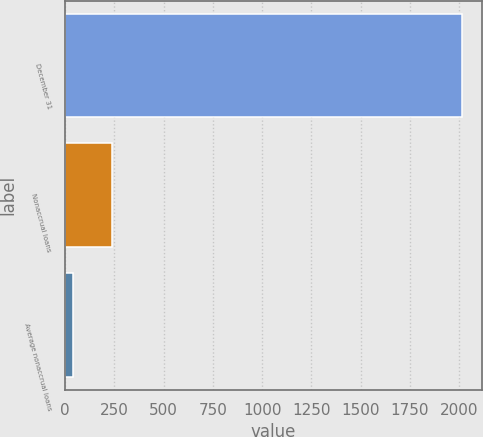<chart> <loc_0><loc_0><loc_500><loc_500><bar_chart><fcel>December 31<fcel>Nonaccrual loans<fcel>Average nonaccrual loans<nl><fcel>2013<fcel>240<fcel>43<nl></chart> 